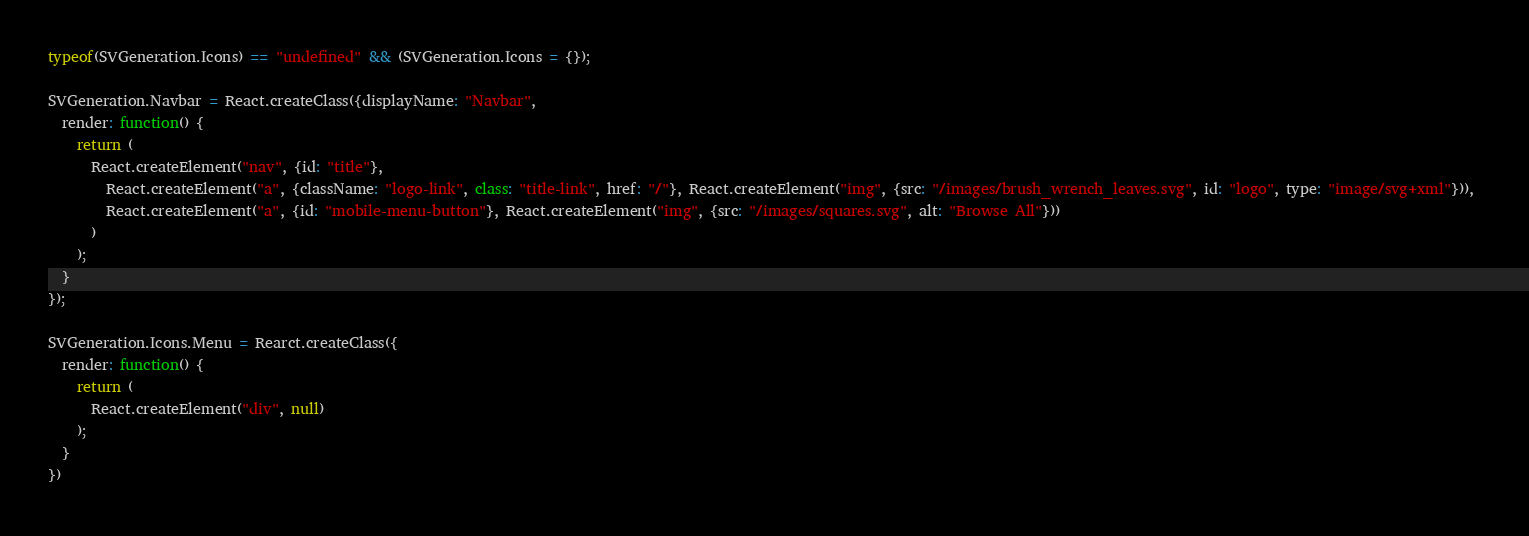Convert code to text. <code><loc_0><loc_0><loc_500><loc_500><_JavaScript_>typeof(SVGeneration.Icons) == "undefined" && (SVGeneration.Icons = {});

SVGeneration.Navbar = React.createClass({displayName: "Navbar",
  render: function() {
    return (
      React.createElement("nav", {id: "title"}, 
        React.createElement("a", {className: "logo-link", class: "title-link", href: "/"}, React.createElement("img", {src: "/images/brush_wrench_leaves.svg", id: "logo", type: "image/svg+xml"})), 
        React.createElement("a", {id: "mobile-menu-button"}, React.createElement("img", {src: "/images/squares.svg", alt: "Browse All"}))
      )
    );
  }
});

SVGeneration.Icons.Menu = Rearct.createClass({
  render: function() {
    return (
      React.createElement("div", null)
    );
  }
})</code> 